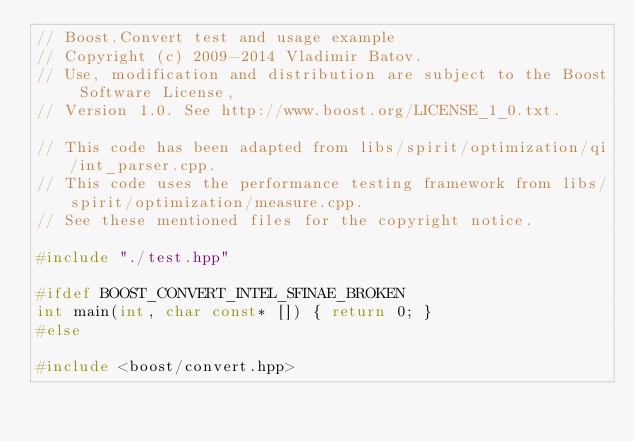<code> <loc_0><loc_0><loc_500><loc_500><_C++_>// Boost.Convert test and usage example
// Copyright (c) 2009-2014 Vladimir Batov.
// Use, modification and distribution are subject to the Boost Software License,
// Version 1.0. See http://www.boost.org/LICENSE_1_0.txt.

// This code has been adapted from libs/spirit/optimization/qi/int_parser.cpp.
// This code uses the performance testing framework from libs/spirit/optimization/measure.cpp.
// See these mentioned files for the copyright notice.

#include "./test.hpp"

#ifdef BOOST_CONVERT_INTEL_SFINAE_BROKEN
int main(int, char const* []) { return 0; }
#else

#include <boost/convert.hpp></code> 